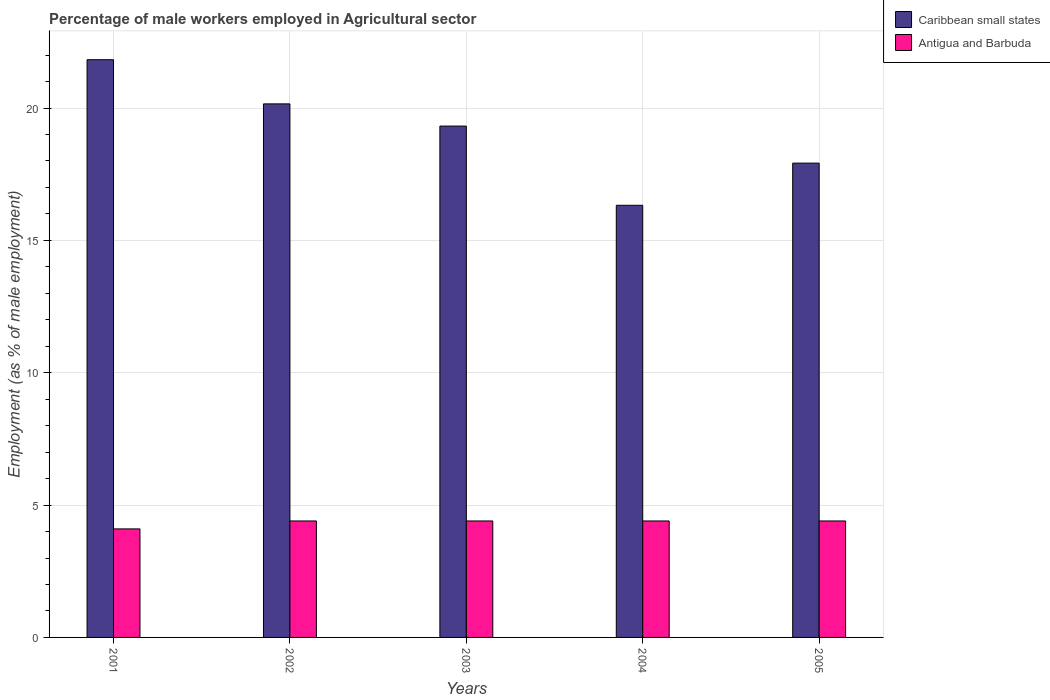How many groups of bars are there?
Your answer should be very brief. 5. Are the number of bars on each tick of the X-axis equal?
Provide a short and direct response. Yes. How many bars are there on the 4th tick from the left?
Provide a short and direct response. 2. What is the percentage of male workers employed in Agricultural sector in Caribbean small states in 2005?
Your response must be concise. 17.92. Across all years, what is the maximum percentage of male workers employed in Agricultural sector in Caribbean small states?
Give a very brief answer. 21.82. Across all years, what is the minimum percentage of male workers employed in Agricultural sector in Antigua and Barbuda?
Provide a short and direct response. 4.1. In which year was the percentage of male workers employed in Agricultural sector in Antigua and Barbuda maximum?
Offer a very short reply. 2002. What is the total percentage of male workers employed in Agricultural sector in Antigua and Barbuda in the graph?
Ensure brevity in your answer.  21.7. What is the difference between the percentage of male workers employed in Agricultural sector in Antigua and Barbuda in 2002 and the percentage of male workers employed in Agricultural sector in Caribbean small states in 2004?
Provide a short and direct response. -11.93. What is the average percentage of male workers employed in Agricultural sector in Antigua and Barbuda per year?
Ensure brevity in your answer.  4.34. In the year 2005, what is the difference between the percentage of male workers employed in Agricultural sector in Antigua and Barbuda and percentage of male workers employed in Agricultural sector in Caribbean small states?
Offer a very short reply. -13.52. In how many years, is the percentage of male workers employed in Agricultural sector in Antigua and Barbuda greater than 8 %?
Your answer should be compact. 0. What is the ratio of the percentage of male workers employed in Agricultural sector in Caribbean small states in 2003 to that in 2004?
Make the answer very short. 1.18. Is the percentage of male workers employed in Agricultural sector in Antigua and Barbuda in 2003 less than that in 2005?
Ensure brevity in your answer.  No. Is the difference between the percentage of male workers employed in Agricultural sector in Antigua and Barbuda in 2001 and 2003 greater than the difference between the percentage of male workers employed in Agricultural sector in Caribbean small states in 2001 and 2003?
Provide a succinct answer. No. What is the difference between the highest and the second highest percentage of male workers employed in Agricultural sector in Caribbean small states?
Provide a short and direct response. 1.67. What is the difference between the highest and the lowest percentage of male workers employed in Agricultural sector in Caribbean small states?
Make the answer very short. 5.5. Is the sum of the percentage of male workers employed in Agricultural sector in Antigua and Barbuda in 2001 and 2005 greater than the maximum percentage of male workers employed in Agricultural sector in Caribbean small states across all years?
Keep it short and to the point. No. What does the 2nd bar from the left in 2002 represents?
Keep it short and to the point. Antigua and Barbuda. What does the 2nd bar from the right in 2003 represents?
Give a very brief answer. Caribbean small states. Are all the bars in the graph horizontal?
Give a very brief answer. No. How many years are there in the graph?
Provide a succinct answer. 5. What is the difference between two consecutive major ticks on the Y-axis?
Offer a terse response. 5. Are the values on the major ticks of Y-axis written in scientific E-notation?
Ensure brevity in your answer.  No. Does the graph contain any zero values?
Offer a very short reply. No. What is the title of the graph?
Offer a very short reply. Percentage of male workers employed in Agricultural sector. Does "Lithuania" appear as one of the legend labels in the graph?
Your answer should be very brief. No. What is the label or title of the Y-axis?
Make the answer very short. Employment (as % of male employment). What is the Employment (as % of male employment) in Caribbean small states in 2001?
Keep it short and to the point. 21.82. What is the Employment (as % of male employment) of Antigua and Barbuda in 2001?
Give a very brief answer. 4.1. What is the Employment (as % of male employment) in Caribbean small states in 2002?
Offer a very short reply. 20.16. What is the Employment (as % of male employment) of Antigua and Barbuda in 2002?
Ensure brevity in your answer.  4.4. What is the Employment (as % of male employment) in Caribbean small states in 2003?
Your response must be concise. 19.32. What is the Employment (as % of male employment) of Antigua and Barbuda in 2003?
Keep it short and to the point. 4.4. What is the Employment (as % of male employment) in Caribbean small states in 2004?
Make the answer very short. 16.33. What is the Employment (as % of male employment) in Antigua and Barbuda in 2004?
Your response must be concise. 4.4. What is the Employment (as % of male employment) in Caribbean small states in 2005?
Provide a succinct answer. 17.92. What is the Employment (as % of male employment) in Antigua and Barbuda in 2005?
Provide a short and direct response. 4.4. Across all years, what is the maximum Employment (as % of male employment) in Caribbean small states?
Make the answer very short. 21.82. Across all years, what is the maximum Employment (as % of male employment) of Antigua and Barbuda?
Your answer should be compact. 4.4. Across all years, what is the minimum Employment (as % of male employment) of Caribbean small states?
Make the answer very short. 16.33. Across all years, what is the minimum Employment (as % of male employment) of Antigua and Barbuda?
Your response must be concise. 4.1. What is the total Employment (as % of male employment) of Caribbean small states in the graph?
Offer a terse response. 95.54. What is the total Employment (as % of male employment) in Antigua and Barbuda in the graph?
Keep it short and to the point. 21.7. What is the difference between the Employment (as % of male employment) in Caribbean small states in 2001 and that in 2002?
Give a very brief answer. 1.67. What is the difference between the Employment (as % of male employment) in Antigua and Barbuda in 2001 and that in 2002?
Give a very brief answer. -0.3. What is the difference between the Employment (as % of male employment) in Caribbean small states in 2001 and that in 2003?
Keep it short and to the point. 2.51. What is the difference between the Employment (as % of male employment) of Caribbean small states in 2001 and that in 2004?
Give a very brief answer. 5.5. What is the difference between the Employment (as % of male employment) in Caribbean small states in 2001 and that in 2005?
Your response must be concise. 3.91. What is the difference between the Employment (as % of male employment) of Caribbean small states in 2002 and that in 2003?
Your answer should be very brief. 0.84. What is the difference between the Employment (as % of male employment) in Antigua and Barbuda in 2002 and that in 2003?
Offer a very short reply. 0. What is the difference between the Employment (as % of male employment) of Caribbean small states in 2002 and that in 2004?
Your answer should be compact. 3.83. What is the difference between the Employment (as % of male employment) in Caribbean small states in 2002 and that in 2005?
Provide a short and direct response. 2.24. What is the difference between the Employment (as % of male employment) of Caribbean small states in 2003 and that in 2004?
Your answer should be compact. 2.99. What is the difference between the Employment (as % of male employment) in Caribbean small states in 2003 and that in 2005?
Ensure brevity in your answer.  1.4. What is the difference between the Employment (as % of male employment) of Antigua and Barbuda in 2003 and that in 2005?
Offer a very short reply. 0. What is the difference between the Employment (as % of male employment) of Caribbean small states in 2004 and that in 2005?
Provide a short and direct response. -1.59. What is the difference between the Employment (as % of male employment) in Caribbean small states in 2001 and the Employment (as % of male employment) in Antigua and Barbuda in 2002?
Provide a succinct answer. 17.42. What is the difference between the Employment (as % of male employment) in Caribbean small states in 2001 and the Employment (as % of male employment) in Antigua and Barbuda in 2003?
Keep it short and to the point. 17.42. What is the difference between the Employment (as % of male employment) of Caribbean small states in 2001 and the Employment (as % of male employment) of Antigua and Barbuda in 2004?
Make the answer very short. 17.42. What is the difference between the Employment (as % of male employment) in Caribbean small states in 2001 and the Employment (as % of male employment) in Antigua and Barbuda in 2005?
Your answer should be very brief. 17.42. What is the difference between the Employment (as % of male employment) of Caribbean small states in 2002 and the Employment (as % of male employment) of Antigua and Barbuda in 2003?
Provide a short and direct response. 15.76. What is the difference between the Employment (as % of male employment) of Caribbean small states in 2002 and the Employment (as % of male employment) of Antigua and Barbuda in 2004?
Your response must be concise. 15.76. What is the difference between the Employment (as % of male employment) in Caribbean small states in 2002 and the Employment (as % of male employment) in Antigua and Barbuda in 2005?
Make the answer very short. 15.76. What is the difference between the Employment (as % of male employment) in Caribbean small states in 2003 and the Employment (as % of male employment) in Antigua and Barbuda in 2004?
Your answer should be compact. 14.92. What is the difference between the Employment (as % of male employment) of Caribbean small states in 2003 and the Employment (as % of male employment) of Antigua and Barbuda in 2005?
Give a very brief answer. 14.92. What is the difference between the Employment (as % of male employment) of Caribbean small states in 2004 and the Employment (as % of male employment) of Antigua and Barbuda in 2005?
Your response must be concise. 11.93. What is the average Employment (as % of male employment) of Caribbean small states per year?
Provide a succinct answer. 19.11. What is the average Employment (as % of male employment) in Antigua and Barbuda per year?
Offer a terse response. 4.34. In the year 2001, what is the difference between the Employment (as % of male employment) in Caribbean small states and Employment (as % of male employment) in Antigua and Barbuda?
Provide a short and direct response. 17.72. In the year 2002, what is the difference between the Employment (as % of male employment) of Caribbean small states and Employment (as % of male employment) of Antigua and Barbuda?
Your answer should be compact. 15.76. In the year 2003, what is the difference between the Employment (as % of male employment) of Caribbean small states and Employment (as % of male employment) of Antigua and Barbuda?
Your answer should be compact. 14.92. In the year 2004, what is the difference between the Employment (as % of male employment) of Caribbean small states and Employment (as % of male employment) of Antigua and Barbuda?
Your answer should be compact. 11.93. In the year 2005, what is the difference between the Employment (as % of male employment) of Caribbean small states and Employment (as % of male employment) of Antigua and Barbuda?
Provide a short and direct response. 13.52. What is the ratio of the Employment (as % of male employment) in Caribbean small states in 2001 to that in 2002?
Your response must be concise. 1.08. What is the ratio of the Employment (as % of male employment) in Antigua and Barbuda in 2001 to that in 2002?
Offer a terse response. 0.93. What is the ratio of the Employment (as % of male employment) in Caribbean small states in 2001 to that in 2003?
Offer a very short reply. 1.13. What is the ratio of the Employment (as % of male employment) in Antigua and Barbuda in 2001 to that in 2003?
Offer a very short reply. 0.93. What is the ratio of the Employment (as % of male employment) of Caribbean small states in 2001 to that in 2004?
Your answer should be very brief. 1.34. What is the ratio of the Employment (as % of male employment) in Antigua and Barbuda in 2001 to that in 2004?
Ensure brevity in your answer.  0.93. What is the ratio of the Employment (as % of male employment) in Caribbean small states in 2001 to that in 2005?
Make the answer very short. 1.22. What is the ratio of the Employment (as % of male employment) of Antigua and Barbuda in 2001 to that in 2005?
Ensure brevity in your answer.  0.93. What is the ratio of the Employment (as % of male employment) in Caribbean small states in 2002 to that in 2003?
Provide a short and direct response. 1.04. What is the ratio of the Employment (as % of male employment) of Antigua and Barbuda in 2002 to that in 2003?
Your answer should be very brief. 1. What is the ratio of the Employment (as % of male employment) of Caribbean small states in 2002 to that in 2004?
Give a very brief answer. 1.23. What is the ratio of the Employment (as % of male employment) in Antigua and Barbuda in 2002 to that in 2004?
Ensure brevity in your answer.  1. What is the ratio of the Employment (as % of male employment) in Caribbean small states in 2002 to that in 2005?
Give a very brief answer. 1.12. What is the ratio of the Employment (as % of male employment) in Antigua and Barbuda in 2002 to that in 2005?
Ensure brevity in your answer.  1. What is the ratio of the Employment (as % of male employment) in Caribbean small states in 2003 to that in 2004?
Make the answer very short. 1.18. What is the ratio of the Employment (as % of male employment) of Antigua and Barbuda in 2003 to that in 2004?
Offer a terse response. 1. What is the ratio of the Employment (as % of male employment) in Caribbean small states in 2003 to that in 2005?
Your answer should be compact. 1.08. What is the ratio of the Employment (as % of male employment) in Caribbean small states in 2004 to that in 2005?
Give a very brief answer. 0.91. What is the ratio of the Employment (as % of male employment) of Antigua and Barbuda in 2004 to that in 2005?
Give a very brief answer. 1. What is the difference between the highest and the second highest Employment (as % of male employment) in Caribbean small states?
Provide a succinct answer. 1.67. What is the difference between the highest and the second highest Employment (as % of male employment) in Antigua and Barbuda?
Ensure brevity in your answer.  0. What is the difference between the highest and the lowest Employment (as % of male employment) in Caribbean small states?
Offer a very short reply. 5.5. What is the difference between the highest and the lowest Employment (as % of male employment) of Antigua and Barbuda?
Keep it short and to the point. 0.3. 